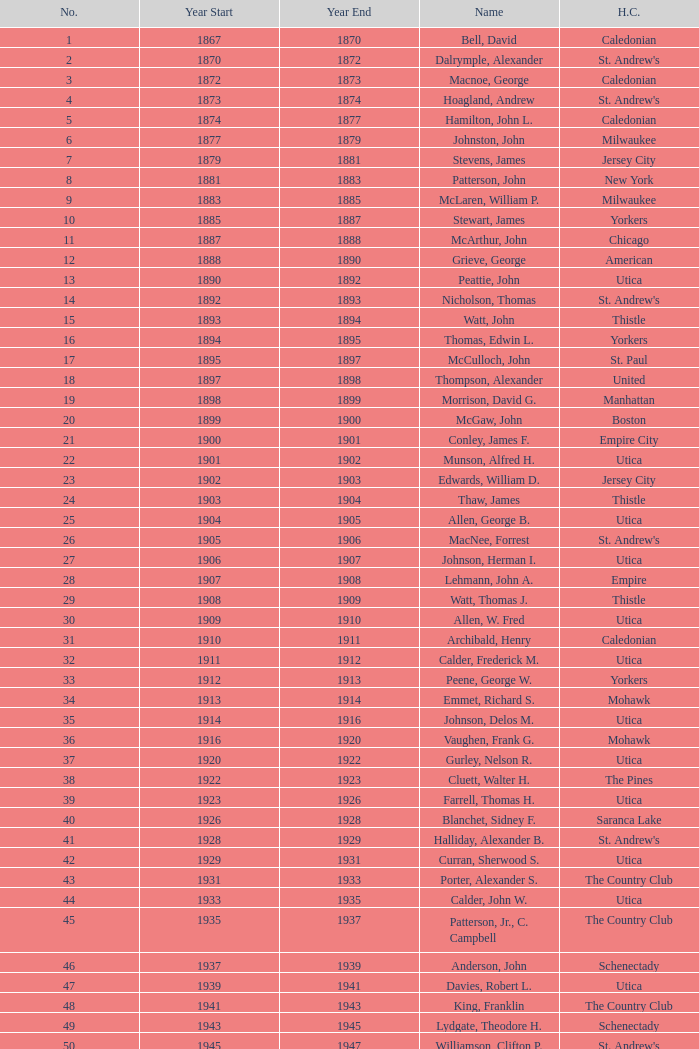Which Number has a Name of hill, lucius t.? 53.0. 